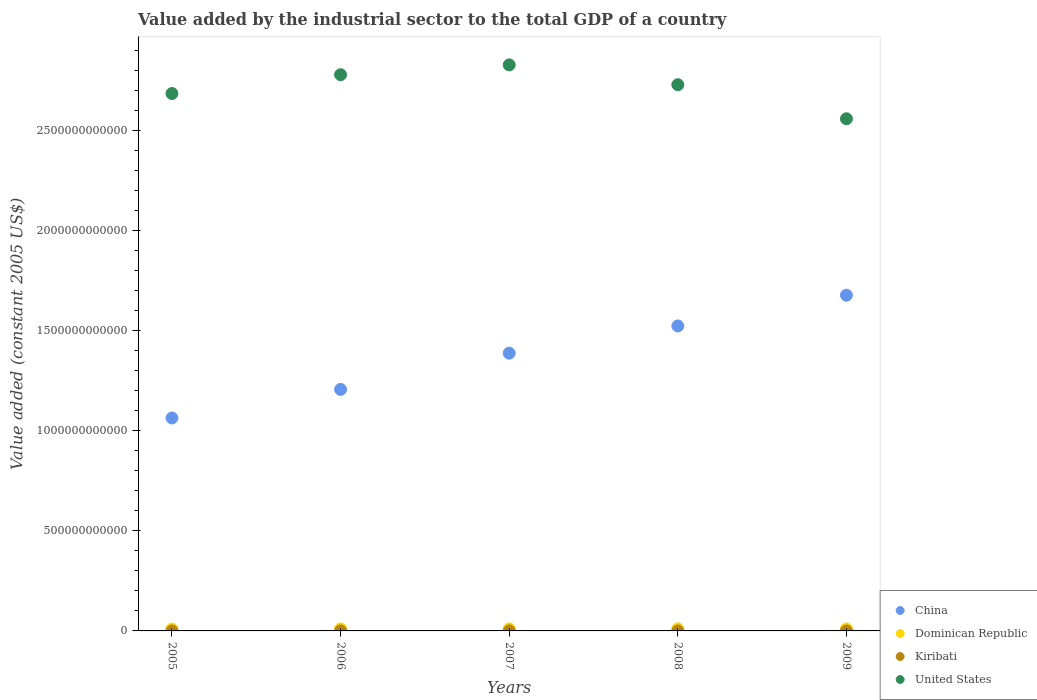How many different coloured dotlines are there?
Your answer should be compact. 4. What is the value added by the industrial sector in Dominican Republic in 2008?
Offer a terse response. 1.03e+1. Across all years, what is the maximum value added by the industrial sector in Dominican Republic?
Make the answer very short. 1.03e+1. Across all years, what is the minimum value added by the industrial sector in Kiribati?
Your answer should be very brief. 7.57e+06. What is the total value added by the industrial sector in China in the graph?
Make the answer very short. 6.85e+12. What is the difference between the value added by the industrial sector in Kiribati in 2006 and that in 2009?
Your response must be concise. -4080.09. What is the difference between the value added by the industrial sector in Kiribati in 2005 and the value added by the industrial sector in United States in 2008?
Keep it short and to the point. -2.73e+12. What is the average value added by the industrial sector in United States per year?
Make the answer very short. 2.71e+12. In the year 2006, what is the difference between the value added by the industrial sector in China and value added by the industrial sector in Dominican Republic?
Your answer should be very brief. 1.20e+12. What is the ratio of the value added by the industrial sector in United States in 2007 to that in 2009?
Your response must be concise. 1.11. Is the value added by the industrial sector in China in 2006 less than that in 2009?
Give a very brief answer. Yes. Is the difference between the value added by the industrial sector in China in 2006 and 2008 greater than the difference between the value added by the industrial sector in Dominican Republic in 2006 and 2008?
Your answer should be compact. No. What is the difference between the highest and the second highest value added by the industrial sector in United States?
Provide a short and direct response. 4.91e+1. What is the difference between the highest and the lowest value added by the industrial sector in Kiribati?
Keep it short and to the point. 1.65e+06. In how many years, is the value added by the industrial sector in China greater than the average value added by the industrial sector in China taken over all years?
Make the answer very short. 3. Is the sum of the value added by the industrial sector in Dominican Republic in 2007 and 2009 greater than the maximum value added by the industrial sector in Kiribati across all years?
Your answer should be compact. Yes. Does the value added by the industrial sector in China monotonically increase over the years?
Keep it short and to the point. Yes. Is the value added by the industrial sector in China strictly less than the value added by the industrial sector in Kiribati over the years?
Your answer should be compact. No. How many years are there in the graph?
Make the answer very short. 5. What is the difference between two consecutive major ticks on the Y-axis?
Your answer should be very brief. 5.00e+11. Does the graph contain any zero values?
Offer a very short reply. No. How many legend labels are there?
Ensure brevity in your answer.  4. What is the title of the graph?
Provide a succinct answer. Value added by the industrial sector to the total GDP of a country. What is the label or title of the X-axis?
Provide a succinct answer. Years. What is the label or title of the Y-axis?
Make the answer very short. Value added (constant 2005 US$). What is the Value added (constant 2005 US$) of China in 2005?
Give a very brief answer. 1.06e+12. What is the Value added (constant 2005 US$) in Dominican Republic in 2005?
Your answer should be very brief. 9.26e+09. What is the Value added (constant 2005 US$) of Kiribati in 2005?
Your answer should be compact. 7.57e+06. What is the Value added (constant 2005 US$) in United States in 2005?
Your response must be concise. 2.68e+12. What is the Value added (constant 2005 US$) of China in 2006?
Your answer should be very brief. 1.21e+12. What is the Value added (constant 2005 US$) of Dominican Republic in 2006?
Provide a succinct answer. 9.86e+09. What is the Value added (constant 2005 US$) of Kiribati in 2006?
Offer a terse response. 7.72e+06. What is the Value added (constant 2005 US$) of United States in 2006?
Give a very brief answer. 2.78e+12. What is the Value added (constant 2005 US$) in China in 2007?
Your answer should be compact. 1.39e+12. What is the Value added (constant 2005 US$) in Dominican Republic in 2007?
Offer a very short reply. 1.01e+1. What is the Value added (constant 2005 US$) of Kiribati in 2007?
Keep it short and to the point. 9.22e+06. What is the Value added (constant 2005 US$) in United States in 2007?
Give a very brief answer. 2.83e+12. What is the Value added (constant 2005 US$) of China in 2008?
Provide a short and direct response. 1.52e+12. What is the Value added (constant 2005 US$) of Dominican Republic in 2008?
Offer a terse response. 1.03e+1. What is the Value added (constant 2005 US$) in Kiribati in 2008?
Offer a very short reply. 8.36e+06. What is the Value added (constant 2005 US$) of United States in 2008?
Keep it short and to the point. 2.73e+12. What is the Value added (constant 2005 US$) in China in 2009?
Make the answer very short. 1.68e+12. What is the Value added (constant 2005 US$) of Dominican Republic in 2009?
Keep it short and to the point. 9.80e+09. What is the Value added (constant 2005 US$) of Kiribati in 2009?
Keep it short and to the point. 7.72e+06. What is the Value added (constant 2005 US$) of United States in 2009?
Your answer should be very brief. 2.56e+12. Across all years, what is the maximum Value added (constant 2005 US$) in China?
Your answer should be compact. 1.68e+12. Across all years, what is the maximum Value added (constant 2005 US$) of Dominican Republic?
Offer a terse response. 1.03e+1. Across all years, what is the maximum Value added (constant 2005 US$) in Kiribati?
Give a very brief answer. 9.22e+06. Across all years, what is the maximum Value added (constant 2005 US$) in United States?
Provide a succinct answer. 2.83e+12. Across all years, what is the minimum Value added (constant 2005 US$) in China?
Provide a succinct answer. 1.06e+12. Across all years, what is the minimum Value added (constant 2005 US$) of Dominican Republic?
Give a very brief answer. 9.26e+09. Across all years, what is the minimum Value added (constant 2005 US$) in Kiribati?
Provide a succinct answer. 7.57e+06. Across all years, what is the minimum Value added (constant 2005 US$) in United States?
Offer a terse response. 2.56e+12. What is the total Value added (constant 2005 US$) in China in the graph?
Your answer should be very brief. 6.85e+12. What is the total Value added (constant 2005 US$) of Dominican Republic in the graph?
Offer a very short reply. 4.94e+1. What is the total Value added (constant 2005 US$) in Kiribati in the graph?
Ensure brevity in your answer.  4.06e+07. What is the total Value added (constant 2005 US$) in United States in the graph?
Your response must be concise. 1.36e+13. What is the difference between the Value added (constant 2005 US$) of China in 2005 and that in 2006?
Provide a short and direct response. -1.43e+11. What is the difference between the Value added (constant 2005 US$) of Dominican Republic in 2005 and that in 2006?
Give a very brief answer. -6.00e+08. What is the difference between the Value added (constant 2005 US$) in Kiribati in 2005 and that in 2006?
Offer a terse response. -1.50e+05. What is the difference between the Value added (constant 2005 US$) in United States in 2005 and that in 2006?
Offer a very short reply. -9.39e+1. What is the difference between the Value added (constant 2005 US$) in China in 2005 and that in 2007?
Keep it short and to the point. -3.24e+11. What is the difference between the Value added (constant 2005 US$) in Dominican Republic in 2005 and that in 2007?
Give a very brief answer. -8.72e+08. What is the difference between the Value added (constant 2005 US$) in Kiribati in 2005 and that in 2007?
Offer a terse response. -1.65e+06. What is the difference between the Value added (constant 2005 US$) of United States in 2005 and that in 2007?
Make the answer very short. -1.43e+11. What is the difference between the Value added (constant 2005 US$) of China in 2005 and that in 2008?
Provide a short and direct response. -4.60e+11. What is the difference between the Value added (constant 2005 US$) of Dominican Republic in 2005 and that in 2008?
Your answer should be very brief. -1.03e+09. What is the difference between the Value added (constant 2005 US$) of Kiribati in 2005 and that in 2008?
Ensure brevity in your answer.  -7.89e+05. What is the difference between the Value added (constant 2005 US$) in United States in 2005 and that in 2008?
Provide a succinct answer. -4.41e+1. What is the difference between the Value added (constant 2005 US$) in China in 2005 and that in 2009?
Your response must be concise. -6.13e+11. What is the difference between the Value added (constant 2005 US$) in Dominican Republic in 2005 and that in 2009?
Give a very brief answer. -5.35e+08. What is the difference between the Value added (constant 2005 US$) in Kiribati in 2005 and that in 2009?
Ensure brevity in your answer.  -1.54e+05. What is the difference between the Value added (constant 2005 US$) in United States in 2005 and that in 2009?
Offer a terse response. 1.26e+11. What is the difference between the Value added (constant 2005 US$) of China in 2006 and that in 2007?
Give a very brief answer. -1.81e+11. What is the difference between the Value added (constant 2005 US$) in Dominican Republic in 2006 and that in 2007?
Make the answer very short. -2.72e+08. What is the difference between the Value added (constant 2005 US$) of Kiribati in 2006 and that in 2007?
Keep it short and to the point. -1.50e+06. What is the difference between the Value added (constant 2005 US$) in United States in 2006 and that in 2007?
Keep it short and to the point. -4.91e+1. What is the difference between the Value added (constant 2005 US$) of China in 2006 and that in 2008?
Your answer should be compact. -3.17e+11. What is the difference between the Value added (constant 2005 US$) in Dominican Republic in 2006 and that in 2008?
Your response must be concise. -4.26e+08. What is the difference between the Value added (constant 2005 US$) of Kiribati in 2006 and that in 2008?
Offer a terse response. -6.39e+05. What is the difference between the Value added (constant 2005 US$) in United States in 2006 and that in 2008?
Offer a terse response. 4.98e+1. What is the difference between the Value added (constant 2005 US$) in China in 2006 and that in 2009?
Your answer should be compact. -4.70e+11. What is the difference between the Value added (constant 2005 US$) in Dominican Republic in 2006 and that in 2009?
Offer a terse response. 6.42e+07. What is the difference between the Value added (constant 2005 US$) of Kiribati in 2006 and that in 2009?
Your answer should be compact. -4080.09. What is the difference between the Value added (constant 2005 US$) in United States in 2006 and that in 2009?
Offer a very short reply. 2.20e+11. What is the difference between the Value added (constant 2005 US$) of China in 2007 and that in 2008?
Give a very brief answer. -1.36e+11. What is the difference between the Value added (constant 2005 US$) in Dominican Republic in 2007 and that in 2008?
Your response must be concise. -1.53e+08. What is the difference between the Value added (constant 2005 US$) of Kiribati in 2007 and that in 2008?
Your answer should be compact. 8.66e+05. What is the difference between the Value added (constant 2005 US$) in United States in 2007 and that in 2008?
Offer a very short reply. 9.89e+1. What is the difference between the Value added (constant 2005 US$) in China in 2007 and that in 2009?
Provide a succinct answer. -2.89e+11. What is the difference between the Value added (constant 2005 US$) in Dominican Republic in 2007 and that in 2009?
Offer a terse response. 3.37e+08. What is the difference between the Value added (constant 2005 US$) of Kiribati in 2007 and that in 2009?
Your response must be concise. 1.50e+06. What is the difference between the Value added (constant 2005 US$) in United States in 2007 and that in 2009?
Make the answer very short. 2.69e+11. What is the difference between the Value added (constant 2005 US$) in China in 2008 and that in 2009?
Your answer should be compact. -1.53e+11. What is the difference between the Value added (constant 2005 US$) in Dominican Republic in 2008 and that in 2009?
Ensure brevity in your answer.  4.90e+08. What is the difference between the Value added (constant 2005 US$) in Kiribati in 2008 and that in 2009?
Ensure brevity in your answer.  6.34e+05. What is the difference between the Value added (constant 2005 US$) of United States in 2008 and that in 2009?
Give a very brief answer. 1.70e+11. What is the difference between the Value added (constant 2005 US$) in China in 2005 and the Value added (constant 2005 US$) in Dominican Republic in 2006?
Ensure brevity in your answer.  1.05e+12. What is the difference between the Value added (constant 2005 US$) in China in 2005 and the Value added (constant 2005 US$) in Kiribati in 2006?
Provide a succinct answer. 1.06e+12. What is the difference between the Value added (constant 2005 US$) of China in 2005 and the Value added (constant 2005 US$) of United States in 2006?
Offer a very short reply. -1.71e+12. What is the difference between the Value added (constant 2005 US$) in Dominican Republic in 2005 and the Value added (constant 2005 US$) in Kiribati in 2006?
Your answer should be compact. 9.26e+09. What is the difference between the Value added (constant 2005 US$) in Dominican Republic in 2005 and the Value added (constant 2005 US$) in United States in 2006?
Keep it short and to the point. -2.77e+12. What is the difference between the Value added (constant 2005 US$) of Kiribati in 2005 and the Value added (constant 2005 US$) of United States in 2006?
Your answer should be compact. -2.78e+12. What is the difference between the Value added (constant 2005 US$) of China in 2005 and the Value added (constant 2005 US$) of Dominican Republic in 2007?
Ensure brevity in your answer.  1.05e+12. What is the difference between the Value added (constant 2005 US$) in China in 2005 and the Value added (constant 2005 US$) in Kiribati in 2007?
Offer a very short reply. 1.06e+12. What is the difference between the Value added (constant 2005 US$) in China in 2005 and the Value added (constant 2005 US$) in United States in 2007?
Keep it short and to the point. -1.76e+12. What is the difference between the Value added (constant 2005 US$) of Dominican Republic in 2005 and the Value added (constant 2005 US$) of Kiribati in 2007?
Provide a short and direct response. 9.26e+09. What is the difference between the Value added (constant 2005 US$) of Dominican Republic in 2005 and the Value added (constant 2005 US$) of United States in 2007?
Your answer should be very brief. -2.82e+12. What is the difference between the Value added (constant 2005 US$) of Kiribati in 2005 and the Value added (constant 2005 US$) of United States in 2007?
Keep it short and to the point. -2.83e+12. What is the difference between the Value added (constant 2005 US$) of China in 2005 and the Value added (constant 2005 US$) of Dominican Republic in 2008?
Ensure brevity in your answer.  1.05e+12. What is the difference between the Value added (constant 2005 US$) in China in 2005 and the Value added (constant 2005 US$) in Kiribati in 2008?
Provide a short and direct response. 1.06e+12. What is the difference between the Value added (constant 2005 US$) in China in 2005 and the Value added (constant 2005 US$) in United States in 2008?
Offer a terse response. -1.66e+12. What is the difference between the Value added (constant 2005 US$) of Dominican Republic in 2005 and the Value added (constant 2005 US$) of Kiribati in 2008?
Provide a succinct answer. 9.26e+09. What is the difference between the Value added (constant 2005 US$) in Dominican Republic in 2005 and the Value added (constant 2005 US$) in United States in 2008?
Provide a succinct answer. -2.72e+12. What is the difference between the Value added (constant 2005 US$) of Kiribati in 2005 and the Value added (constant 2005 US$) of United States in 2008?
Offer a very short reply. -2.73e+12. What is the difference between the Value added (constant 2005 US$) in China in 2005 and the Value added (constant 2005 US$) in Dominican Republic in 2009?
Offer a very short reply. 1.05e+12. What is the difference between the Value added (constant 2005 US$) in China in 2005 and the Value added (constant 2005 US$) in Kiribati in 2009?
Provide a succinct answer. 1.06e+12. What is the difference between the Value added (constant 2005 US$) in China in 2005 and the Value added (constant 2005 US$) in United States in 2009?
Your response must be concise. -1.49e+12. What is the difference between the Value added (constant 2005 US$) in Dominican Republic in 2005 and the Value added (constant 2005 US$) in Kiribati in 2009?
Ensure brevity in your answer.  9.26e+09. What is the difference between the Value added (constant 2005 US$) in Dominican Republic in 2005 and the Value added (constant 2005 US$) in United States in 2009?
Offer a terse response. -2.55e+12. What is the difference between the Value added (constant 2005 US$) of Kiribati in 2005 and the Value added (constant 2005 US$) of United States in 2009?
Ensure brevity in your answer.  -2.56e+12. What is the difference between the Value added (constant 2005 US$) in China in 2006 and the Value added (constant 2005 US$) in Dominican Republic in 2007?
Provide a short and direct response. 1.20e+12. What is the difference between the Value added (constant 2005 US$) in China in 2006 and the Value added (constant 2005 US$) in Kiribati in 2007?
Offer a very short reply. 1.21e+12. What is the difference between the Value added (constant 2005 US$) of China in 2006 and the Value added (constant 2005 US$) of United States in 2007?
Ensure brevity in your answer.  -1.62e+12. What is the difference between the Value added (constant 2005 US$) of Dominican Republic in 2006 and the Value added (constant 2005 US$) of Kiribati in 2007?
Your response must be concise. 9.85e+09. What is the difference between the Value added (constant 2005 US$) in Dominican Republic in 2006 and the Value added (constant 2005 US$) in United States in 2007?
Give a very brief answer. -2.82e+12. What is the difference between the Value added (constant 2005 US$) in Kiribati in 2006 and the Value added (constant 2005 US$) in United States in 2007?
Your answer should be very brief. -2.83e+12. What is the difference between the Value added (constant 2005 US$) in China in 2006 and the Value added (constant 2005 US$) in Dominican Republic in 2008?
Ensure brevity in your answer.  1.20e+12. What is the difference between the Value added (constant 2005 US$) in China in 2006 and the Value added (constant 2005 US$) in Kiribati in 2008?
Provide a succinct answer. 1.21e+12. What is the difference between the Value added (constant 2005 US$) in China in 2006 and the Value added (constant 2005 US$) in United States in 2008?
Your answer should be very brief. -1.52e+12. What is the difference between the Value added (constant 2005 US$) in Dominican Republic in 2006 and the Value added (constant 2005 US$) in Kiribati in 2008?
Make the answer very short. 9.86e+09. What is the difference between the Value added (constant 2005 US$) in Dominican Republic in 2006 and the Value added (constant 2005 US$) in United States in 2008?
Ensure brevity in your answer.  -2.72e+12. What is the difference between the Value added (constant 2005 US$) in Kiribati in 2006 and the Value added (constant 2005 US$) in United States in 2008?
Provide a short and direct response. -2.73e+12. What is the difference between the Value added (constant 2005 US$) of China in 2006 and the Value added (constant 2005 US$) of Dominican Republic in 2009?
Give a very brief answer. 1.20e+12. What is the difference between the Value added (constant 2005 US$) in China in 2006 and the Value added (constant 2005 US$) in Kiribati in 2009?
Your answer should be compact. 1.21e+12. What is the difference between the Value added (constant 2005 US$) in China in 2006 and the Value added (constant 2005 US$) in United States in 2009?
Give a very brief answer. -1.35e+12. What is the difference between the Value added (constant 2005 US$) in Dominican Republic in 2006 and the Value added (constant 2005 US$) in Kiribati in 2009?
Make the answer very short. 9.86e+09. What is the difference between the Value added (constant 2005 US$) in Dominican Republic in 2006 and the Value added (constant 2005 US$) in United States in 2009?
Offer a very short reply. -2.55e+12. What is the difference between the Value added (constant 2005 US$) of Kiribati in 2006 and the Value added (constant 2005 US$) of United States in 2009?
Make the answer very short. -2.56e+12. What is the difference between the Value added (constant 2005 US$) of China in 2007 and the Value added (constant 2005 US$) of Dominican Republic in 2008?
Offer a very short reply. 1.38e+12. What is the difference between the Value added (constant 2005 US$) of China in 2007 and the Value added (constant 2005 US$) of Kiribati in 2008?
Your answer should be compact. 1.39e+12. What is the difference between the Value added (constant 2005 US$) in China in 2007 and the Value added (constant 2005 US$) in United States in 2008?
Provide a short and direct response. -1.34e+12. What is the difference between the Value added (constant 2005 US$) in Dominican Republic in 2007 and the Value added (constant 2005 US$) in Kiribati in 2008?
Give a very brief answer. 1.01e+1. What is the difference between the Value added (constant 2005 US$) of Dominican Republic in 2007 and the Value added (constant 2005 US$) of United States in 2008?
Provide a short and direct response. -2.72e+12. What is the difference between the Value added (constant 2005 US$) in Kiribati in 2007 and the Value added (constant 2005 US$) in United States in 2008?
Ensure brevity in your answer.  -2.73e+12. What is the difference between the Value added (constant 2005 US$) of China in 2007 and the Value added (constant 2005 US$) of Dominican Republic in 2009?
Provide a short and direct response. 1.38e+12. What is the difference between the Value added (constant 2005 US$) of China in 2007 and the Value added (constant 2005 US$) of Kiribati in 2009?
Your response must be concise. 1.39e+12. What is the difference between the Value added (constant 2005 US$) of China in 2007 and the Value added (constant 2005 US$) of United States in 2009?
Give a very brief answer. -1.17e+12. What is the difference between the Value added (constant 2005 US$) in Dominican Republic in 2007 and the Value added (constant 2005 US$) in Kiribati in 2009?
Make the answer very short. 1.01e+1. What is the difference between the Value added (constant 2005 US$) in Dominican Republic in 2007 and the Value added (constant 2005 US$) in United States in 2009?
Give a very brief answer. -2.55e+12. What is the difference between the Value added (constant 2005 US$) in Kiribati in 2007 and the Value added (constant 2005 US$) in United States in 2009?
Offer a terse response. -2.56e+12. What is the difference between the Value added (constant 2005 US$) of China in 2008 and the Value added (constant 2005 US$) of Dominican Republic in 2009?
Give a very brief answer. 1.51e+12. What is the difference between the Value added (constant 2005 US$) in China in 2008 and the Value added (constant 2005 US$) in Kiribati in 2009?
Offer a very short reply. 1.52e+12. What is the difference between the Value added (constant 2005 US$) of China in 2008 and the Value added (constant 2005 US$) of United States in 2009?
Offer a very short reply. -1.03e+12. What is the difference between the Value added (constant 2005 US$) of Dominican Republic in 2008 and the Value added (constant 2005 US$) of Kiribati in 2009?
Keep it short and to the point. 1.03e+1. What is the difference between the Value added (constant 2005 US$) of Dominican Republic in 2008 and the Value added (constant 2005 US$) of United States in 2009?
Provide a short and direct response. -2.55e+12. What is the difference between the Value added (constant 2005 US$) in Kiribati in 2008 and the Value added (constant 2005 US$) in United States in 2009?
Your answer should be compact. -2.56e+12. What is the average Value added (constant 2005 US$) in China per year?
Your response must be concise. 1.37e+12. What is the average Value added (constant 2005 US$) of Dominican Republic per year?
Make the answer very short. 9.87e+09. What is the average Value added (constant 2005 US$) in Kiribati per year?
Offer a terse response. 8.12e+06. What is the average Value added (constant 2005 US$) in United States per year?
Give a very brief answer. 2.71e+12. In the year 2005, what is the difference between the Value added (constant 2005 US$) of China and Value added (constant 2005 US$) of Dominican Republic?
Offer a terse response. 1.05e+12. In the year 2005, what is the difference between the Value added (constant 2005 US$) in China and Value added (constant 2005 US$) in Kiribati?
Offer a terse response. 1.06e+12. In the year 2005, what is the difference between the Value added (constant 2005 US$) in China and Value added (constant 2005 US$) in United States?
Keep it short and to the point. -1.62e+12. In the year 2005, what is the difference between the Value added (constant 2005 US$) in Dominican Republic and Value added (constant 2005 US$) in Kiribati?
Your answer should be very brief. 9.26e+09. In the year 2005, what is the difference between the Value added (constant 2005 US$) of Dominican Republic and Value added (constant 2005 US$) of United States?
Your response must be concise. -2.67e+12. In the year 2005, what is the difference between the Value added (constant 2005 US$) of Kiribati and Value added (constant 2005 US$) of United States?
Provide a succinct answer. -2.68e+12. In the year 2006, what is the difference between the Value added (constant 2005 US$) in China and Value added (constant 2005 US$) in Dominican Republic?
Make the answer very short. 1.20e+12. In the year 2006, what is the difference between the Value added (constant 2005 US$) of China and Value added (constant 2005 US$) of Kiribati?
Offer a very short reply. 1.21e+12. In the year 2006, what is the difference between the Value added (constant 2005 US$) of China and Value added (constant 2005 US$) of United States?
Keep it short and to the point. -1.57e+12. In the year 2006, what is the difference between the Value added (constant 2005 US$) in Dominican Republic and Value added (constant 2005 US$) in Kiribati?
Your response must be concise. 9.86e+09. In the year 2006, what is the difference between the Value added (constant 2005 US$) in Dominican Republic and Value added (constant 2005 US$) in United States?
Make the answer very short. -2.77e+12. In the year 2006, what is the difference between the Value added (constant 2005 US$) in Kiribati and Value added (constant 2005 US$) in United States?
Offer a very short reply. -2.78e+12. In the year 2007, what is the difference between the Value added (constant 2005 US$) of China and Value added (constant 2005 US$) of Dominican Republic?
Keep it short and to the point. 1.38e+12. In the year 2007, what is the difference between the Value added (constant 2005 US$) of China and Value added (constant 2005 US$) of Kiribati?
Offer a very short reply. 1.39e+12. In the year 2007, what is the difference between the Value added (constant 2005 US$) of China and Value added (constant 2005 US$) of United States?
Give a very brief answer. -1.44e+12. In the year 2007, what is the difference between the Value added (constant 2005 US$) of Dominican Republic and Value added (constant 2005 US$) of Kiribati?
Make the answer very short. 1.01e+1. In the year 2007, what is the difference between the Value added (constant 2005 US$) in Dominican Republic and Value added (constant 2005 US$) in United States?
Keep it short and to the point. -2.82e+12. In the year 2007, what is the difference between the Value added (constant 2005 US$) in Kiribati and Value added (constant 2005 US$) in United States?
Your answer should be very brief. -2.83e+12. In the year 2008, what is the difference between the Value added (constant 2005 US$) of China and Value added (constant 2005 US$) of Dominican Republic?
Your response must be concise. 1.51e+12. In the year 2008, what is the difference between the Value added (constant 2005 US$) in China and Value added (constant 2005 US$) in Kiribati?
Make the answer very short. 1.52e+12. In the year 2008, what is the difference between the Value added (constant 2005 US$) in China and Value added (constant 2005 US$) in United States?
Provide a short and direct response. -1.20e+12. In the year 2008, what is the difference between the Value added (constant 2005 US$) of Dominican Republic and Value added (constant 2005 US$) of Kiribati?
Make the answer very short. 1.03e+1. In the year 2008, what is the difference between the Value added (constant 2005 US$) in Dominican Republic and Value added (constant 2005 US$) in United States?
Your response must be concise. -2.72e+12. In the year 2008, what is the difference between the Value added (constant 2005 US$) of Kiribati and Value added (constant 2005 US$) of United States?
Offer a terse response. -2.73e+12. In the year 2009, what is the difference between the Value added (constant 2005 US$) in China and Value added (constant 2005 US$) in Dominican Republic?
Offer a very short reply. 1.67e+12. In the year 2009, what is the difference between the Value added (constant 2005 US$) in China and Value added (constant 2005 US$) in Kiribati?
Your response must be concise. 1.68e+12. In the year 2009, what is the difference between the Value added (constant 2005 US$) in China and Value added (constant 2005 US$) in United States?
Offer a terse response. -8.81e+11. In the year 2009, what is the difference between the Value added (constant 2005 US$) in Dominican Republic and Value added (constant 2005 US$) in Kiribati?
Your answer should be very brief. 9.79e+09. In the year 2009, what is the difference between the Value added (constant 2005 US$) of Dominican Republic and Value added (constant 2005 US$) of United States?
Your answer should be compact. -2.55e+12. In the year 2009, what is the difference between the Value added (constant 2005 US$) of Kiribati and Value added (constant 2005 US$) of United States?
Ensure brevity in your answer.  -2.56e+12. What is the ratio of the Value added (constant 2005 US$) in China in 2005 to that in 2006?
Ensure brevity in your answer.  0.88. What is the ratio of the Value added (constant 2005 US$) in Dominican Republic in 2005 to that in 2006?
Your response must be concise. 0.94. What is the ratio of the Value added (constant 2005 US$) of Kiribati in 2005 to that in 2006?
Your answer should be compact. 0.98. What is the ratio of the Value added (constant 2005 US$) of United States in 2005 to that in 2006?
Your answer should be very brief. 0.97. What is the ratio of the Value added (constant 2005 US$) in China in 2005 to that in 2007?
Your answer should be compact. 0.77. What is the ratio of the Value added (constant 2005 US$) of Dominican Republic in 2005 to that in 2007?
Keep it short and to the point. 0.91. What is the ratio of the Value added (constant 2005 US$) of Kiribati in 2005 to that in 2007?
Provide a succinct answer. 0.82. What is the ratio of the Value added (constant 2005 US$) of United States in 2005 to that in 2007?
Give a very brief answer. 0.95. What is the ratio of the Value added (constant 2005 US$) in China in 2005 to that in 2008?
Provide a short and direct response. 0.7. What is the ratio of the Value added (constant 2005 US$) of Dominican Republic in 2005 to that in 2008?
Provide a succinct answer. 0.9. What is the ratio of the Value added (constant 2005 US$) in Kiribati in 2005 to that in 2008?
Your answer should be compact. 0.91. What is the ratio of the Value added (constant 2005 US$) of United States in 2005 to that in 2008?
Make the answer very short. 0.98. What is the ratio of the Value added (constant 2005 US$) of China in 2005 to that in 2009?
Your answer should be compact. 0.63. What is the ratio of the Value added (constant 2005 US$) of Dominican Republic in 2005 to that in 2009?
Provide a short and direct response. 0.95. What is the ratio of the Value added (constant 2005 US$) in United States in 2005 to that in 2009?
Your answer should be very brief. 1.05. What is the ratio of the Value added (constant 2005 US$) in China in 2006 to that in 2007?
Provide a short and direct response. 0.87. What is the ratio of the Value added (constant 2005 US$) of Dominican Republic in 2006 to that in 2007?
Provide a succinct answer. 0.97. What is the ratio of the Value added (constant 2005 US$) of Kiribati in 2006 to that in 2007?
Offer a terse response. 0.84. What is the ratio of the Value added (constant 2005 US$) of United States in 2006 to that in 2007?
Provide a succinct answer. 0.98. What is the ratio of the Value added (constant 2005 US$) of China in 2006 to that in 2008?
Offer a very short reply. 0.79. What is the ratio of the Value added (constant 2005 US$) in Dominican Republic in 2006 to that in 2008?
Ensure brevity in your answer.  0.96. What is the ratio of the Value added (constant 2005 US$) in Kiribati in 2006 to that in 2008?
Your answer should be compact. 0.92. What is the ratio of the Value added (constant 2005 US$) of United States in 2006 to that in 2008?
Keep it short and to the point. 1.02. What is the ratio of the Value added (constant 2005 US$) of China in 2006 to that in 2009?
Your response must be concise. 0.72. What is the ratio of the Value added (constant 2005 US$) of Dominican Republic in 2006 to that in 2009?
Your response must be concise. 1.01. What is the ratio of the Value added (constant 2005 US$) in Kiribati in 2006 to that in 2009?
Your response must be concise. 1. What is the ratio of the Value added (constant 2005 US$) of United States in 2006 to that in 2009?
Ensure brevity in your answer.  1.09. What is the ratio of the Value added (constant 2005 US$) in China in 2007 to that in 2008?
Your response must be concise. 0.91. What is the ratio of the Value added (constant 2005 US$) in Dominican Republic in 2007 to that in 2008?
Your answer should be compact. 0.99. What is the ratio of the Value added (constant 2005 US$) of Kiribati in 2007 to that in 2008?
Your response must be concise. 1.1. What is the ratio of the Value added (constant 2005 US$) in United States in 2007 to that in 2008?
Ensure brevity in your answer.  1.04. What is the ratio of the Value added (constant 2005 US$) in China in 2007 to that in 2009?
Make the answer very short. 0.83. What is the ratio of the Value added (constant 2005 US$) in Dominican Republic in 2007 to that in 2009?
Offer a terse response. 1.03. What is the ratio of the Value added (constant 2005 US$) in Kiribati in 2007 to that in 2009?
Offer a terse response. 1.19. What is the ratio of the Value added (constant 2005 US$) in United States in 2007 to that in 2009?
Your answer should be compact. 1.11. What is the ratio of the Value added (constant 2005 US$) in China in 2008 to that in 2009?
Offer a terse response. 0.91. What is the ratio of the Value added (constant 2005 US$) in Dominican Republic in 2008 to that in 2009?
Your answer should be compact. 1.05. What is the ratio of the Value added (constant 2005 US$) in Kiribati in 2008 to that in 2009?
Provide a succinct answer. 1.08. What is the ratio of the Value added (constant 2005 US$) in United States in 2008 to that in 2009?
Your response must be concise. 1.07. What is the difference between the highest and the second highest Value added (constant 2005 US$) of China?
Offer a terse response. 1.53e+11. What is the difference between the highest and the second highest Value added (constant 2005 US$) in Dominican Republic?
Offer a very short reply. 1.53e+08. What is the difference between the highest and the second highest Value added (constant 2005 US$) of Kiribati?
Keep it short and to the point. 8.66e+05. What is the difference between the highest and the second highest Value added (constant 2005 US$) in United States?
Provide a succinct answer. 4.91e+1. What is the difference between the highest and the lowest Value added (constant 2005 US$) of China?
Provide a succinct answer. 6.13e+11. What is the difference between the highest and the lowest Value added (constant 2005 US$) in Dominican Republic?
Your answer should be compact. 1.03e+09. What is the difference between the highest and the lowest Value added (constant 2005 US$) of Kiribati?
Make the answer very short. 1.65e+06. What is the difference between the highest and the lowest Value added (constant 2005 US$) of United States?
Ensure brevity in your answer.  2.69e+11. 